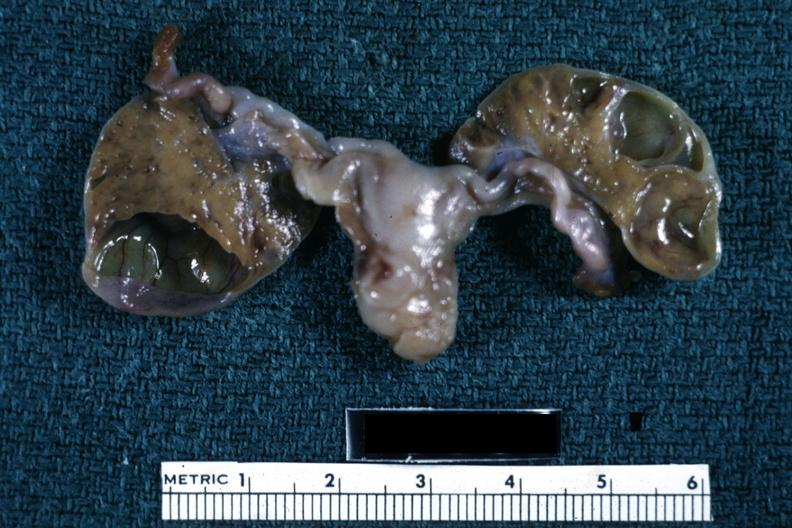s theca luteum cysts in newborn present?
Answer the question using a single word or phrase. Yes 